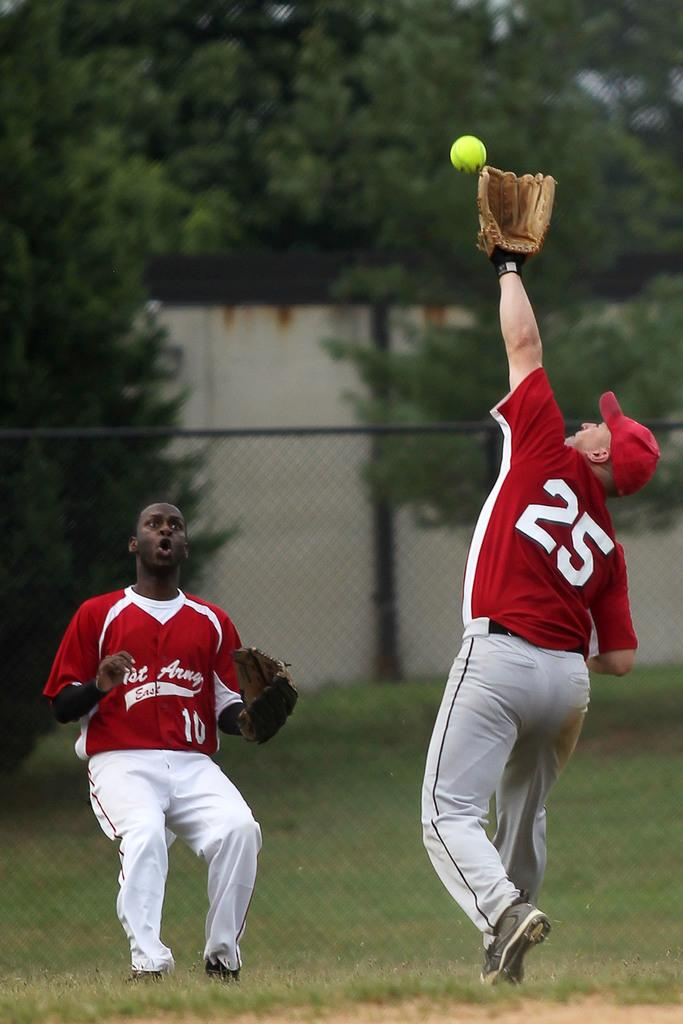<image>
Summarize the visual content of the image. Number 10 is surprised that number 25 is trying to catch this ball. 